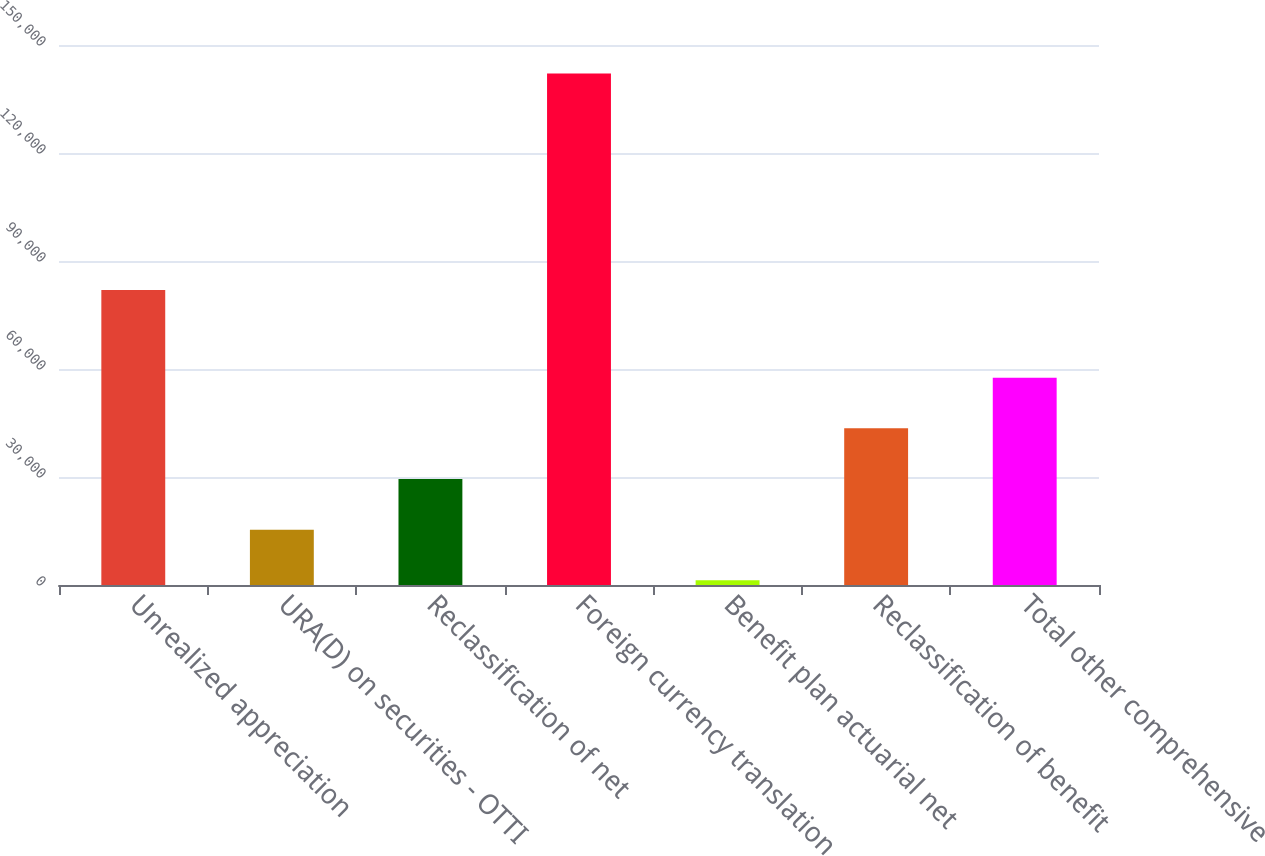Convert chart to OTSL. <chart><loc_0><loc_0><loc_500><loc_500><bar_chart><fcel>Unrealized appreciation<fcel>URA(D) on securities - OTTI<fcel>Reclassification of net<fcel>Foreign currency translation<fcel>Benefit plan actuarial net<fcel>Reclassification of benefit<fcel>Total other comprehensive<nl><fcel>81915<fcel>15375.4<fcel>29450.8<fcel>142054<fcel>1300<fcel>43526.2<fcel>57601.6<nl></chart> 